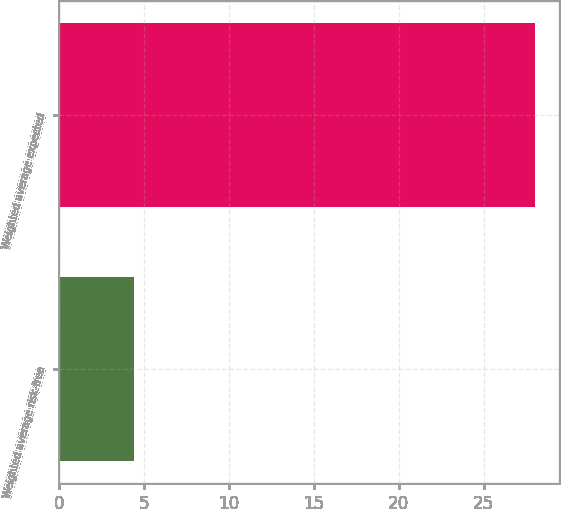<chart> <loc_0><loc_0><loc_500><loc_500><bar_chart><fcel>Weighted average risk-free<fcel>Weighted average expected<nl><fcel>4.4<fcel>28<nl></chart> 